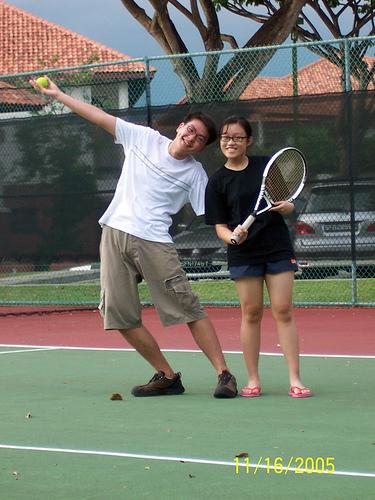What is the man holding?
Answer briefly. Ball. Is tennis a highly physical sport?
Answer briefly. Yes. What color is his shirt?
Give a very brief answer. White. What kind of shoes is the man wearing?
Write a very short answer. Sneakers. What is on the ground under the player?
Quick response, please. Tennis court. What letters are in the lowest right hand corner?
Short answer required. 11/16/2005. What color is the lady wearing?
Write a very short answer. Black. Is everyone in this photo wearing shoes?
Keep it brief. Yes. Is she playing on clay?
Quick response, please. No. Is this a local tennis court?
Keep it brief. Yes. Do you think this player is talented?
Short answer required. No. Are his feet touching the ground?
Concise answer only. Yes. What type of footwear is the girl wearing?
Concise answer only. Flip flops. What type of turf is being played on?
Concise answer only. Clay. Is the man going to hit the ball?
Answer briefly. No. What did the girl just do?
Short answer required. Pose. 